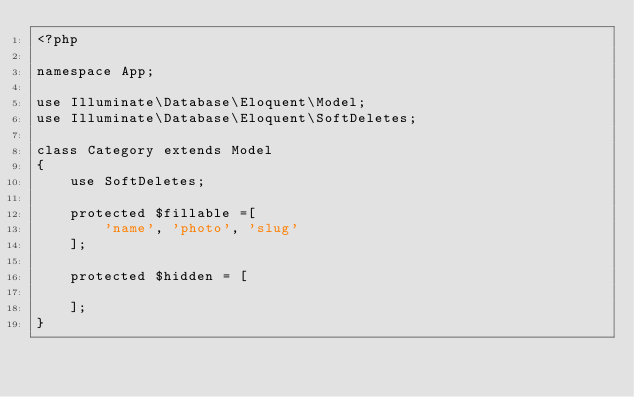<code> <loc_0><loc_0><loc_500><loc_500><_PHP_><?php

namespace App;

use Illuminate\Database\Eloquent\Model;
use Illuminate\Database\Eloquent\SoftDeletes;

class Category extends Model
{
    use SoftDeletes;

    protected $fillable =[
        'name', 'photo', 'slug'
    ];

    protected $hidden = [

    ];
}   
</code> 